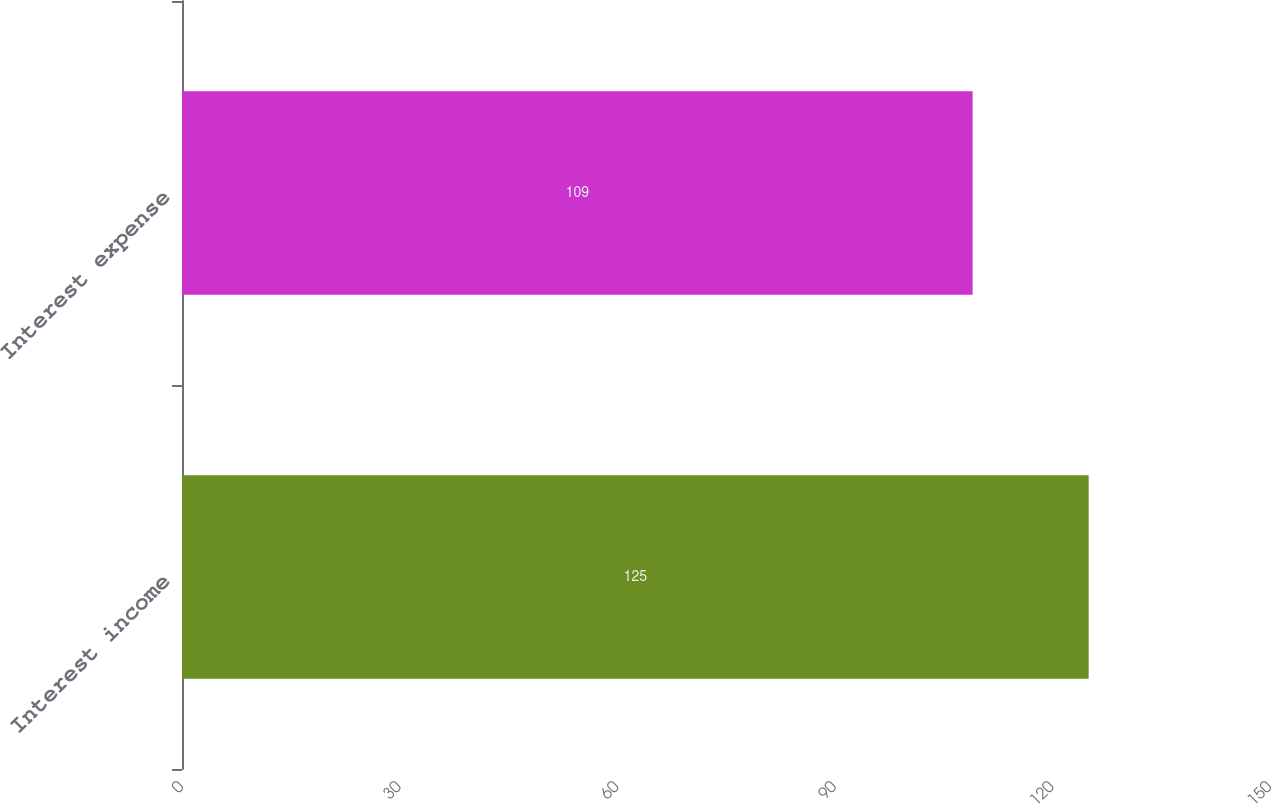<chart> <loc_0><loc_0><loc_500><loc_500><bar_chart><fcel>Interest income<fcel>Interest expense<nl><fcel>125<fcel>109<nl></chart> 